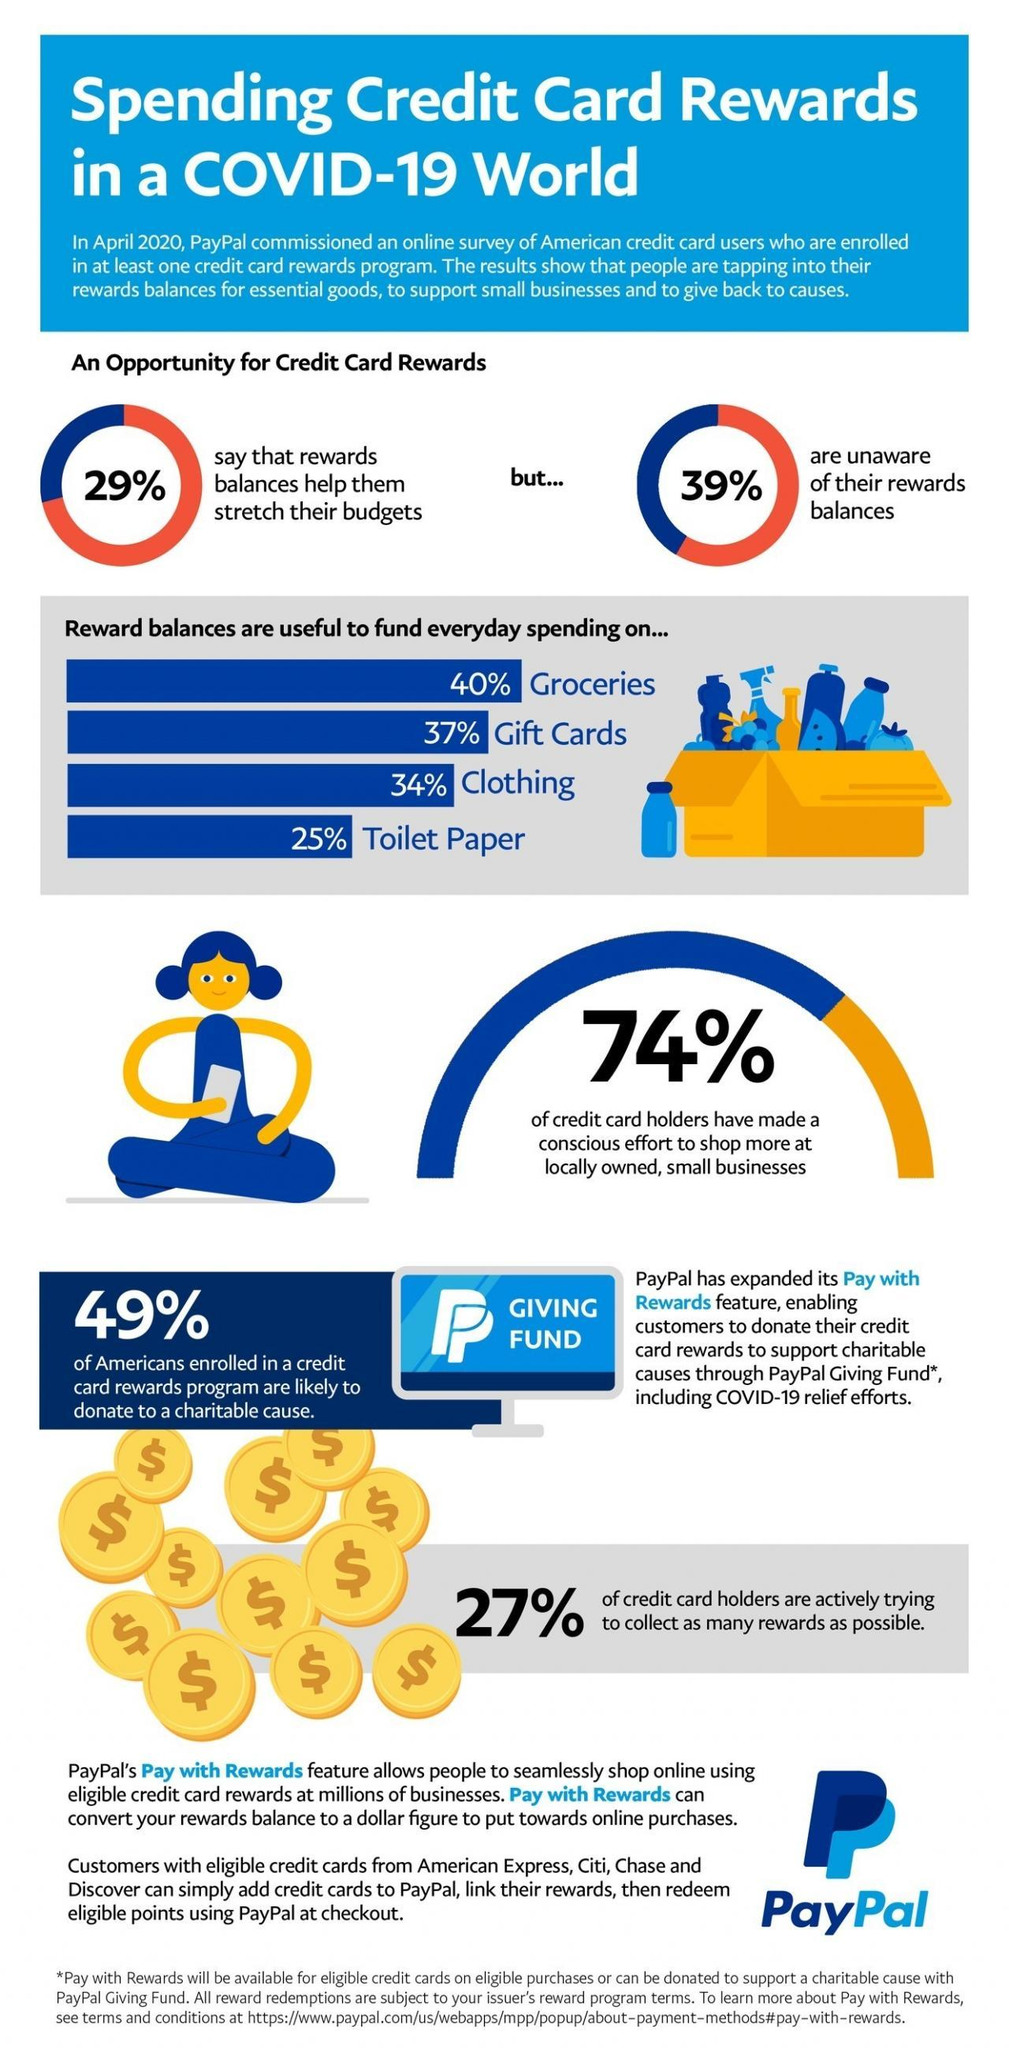What percent of credit card reward balances were spend on groceries according to the survey conducted by PayPal in April 2020?
Answer the question with a short phrase. 40% What percentage of American credit card holders are not actively trying to collect as many rewards as possible according to the survey conducted by PayPal in April 2020? 73% What percent of credit card reward balances were spend on clothing according to the survey conducted by PayPal in April 2020? 34% What percentage of American credit card holders are aware of their reward balances according to the survey conducted by PayPal in April 2020? 61% What percent of credit card reward balances were spend on gift cards according to the survey conducted by PayPal in April 2020? 37% 